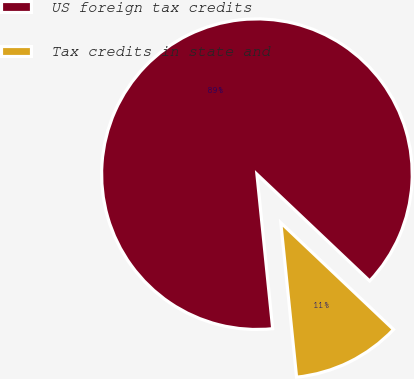Convert chart. <chart><loc_0><loc_0><loc_500><loc_500><pie_chart><fcel>US foreign tax credits<fcel>Tax credits in state and<nl><fcel>88.69%<fcel>11.31%<nl></chart> 